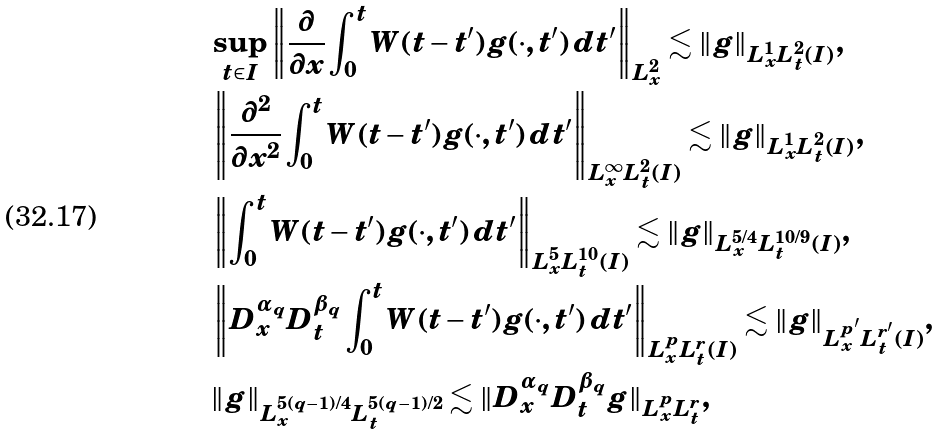Convert formula to latex. <formula><loc_0><loc_0><loc_500><loc_500>& \sup _ { t \in I } \left \| \frac { \partial } { \partial x } \int _ { 0 } ^ { t } W ( t - t ^ { \prime } ) g ( \cdot , t ^ { \prime } ) \, d t ^ { \prime } \right \| _ { L ^ { 2 } _ { x } } \lesssim \| g \| _ { L ^ { 1 } _ { x } L ^ { 2 } _ { t } ( I ) } , \\ & \left \| \frac { \partial ^ { 2 } } { \partial x ^ { 2 } } \int _ { 0 } ^ { t } W ( t - t ^ { \prime } ) g ( \cdot , t ^ { \prime } ) \, d t ^ { \prime } \right \| _ { L ^ { \infty } _ { x } L ^ { 2 } _ { t } ( I ) } \lesssim \| g \| _ { L ^ { 1 } _ { x } L ^ { 2 } _ { t } ( I ) } , \\ & \left \| \int _ { 0 } ^ { t } W ( t - t ^ { \prime } ) g ( \cdot , t ^ { \prime } ) \, d t ^ { \prime } \right \| _ { L ^ { 5 } _ { x } L ^ { 1 0 } _ { t } ( I ) } \lesssim \| g \| _ { L ^ { 5 / 4 } _ { x } L ^ { 1 0 / 9 } _ { t } ( I ) } , \\ & \left \| D ^ { \alpha _ { q } } _ { x } D ^ { \beta _ { q } } _ { t } \int _ { 0 } ^ { t } W ( t - t ^ { \prime } ) g ( \cdot , t ^ { \prime } ) \, d t ^ { \prime } \right \| _ { L ^ { p } _ { x } L ^ { r } _ { t } ( I ) } \lesssim \| g \| _ { L ^ { p ^ { \prime } } _ { x } L ^ { r ^ { \prime } } _ { t } ( I ) } , \\ & \| g \| _ { L ^ { 5 ( q - 1 ) / 4 } _ { x } L ^ { 5 ( q - 1 ) / 2 } _ { t } } \lesssim \| D ^ { \alpha _ { q } } _ { x } D ^ { \beta _ { q } } _ { t } g \| _ { L ^ { p } _ { x } L ^ { r } _ { t } } ,</formula> 